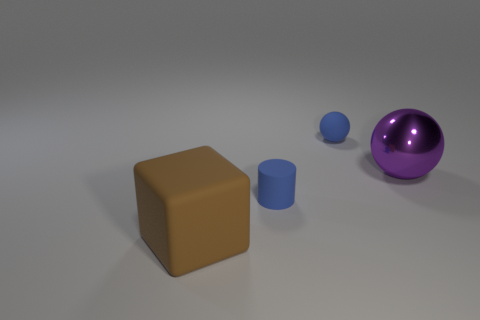Add 3 blue spheres. How many objects exist? 7 Subtract all cylinders. How many objects are left? 3 Subtract 0 purple cylinders. How many objects are left? 4 Subtract all big blocks. Subtract all yellow metal spheres. How many objects are left? 3 Add 3 brown blocks. How many brown blocks are left? 4 Add 2 tiny brown matte things. How many tiny brown matte things exist? 2 